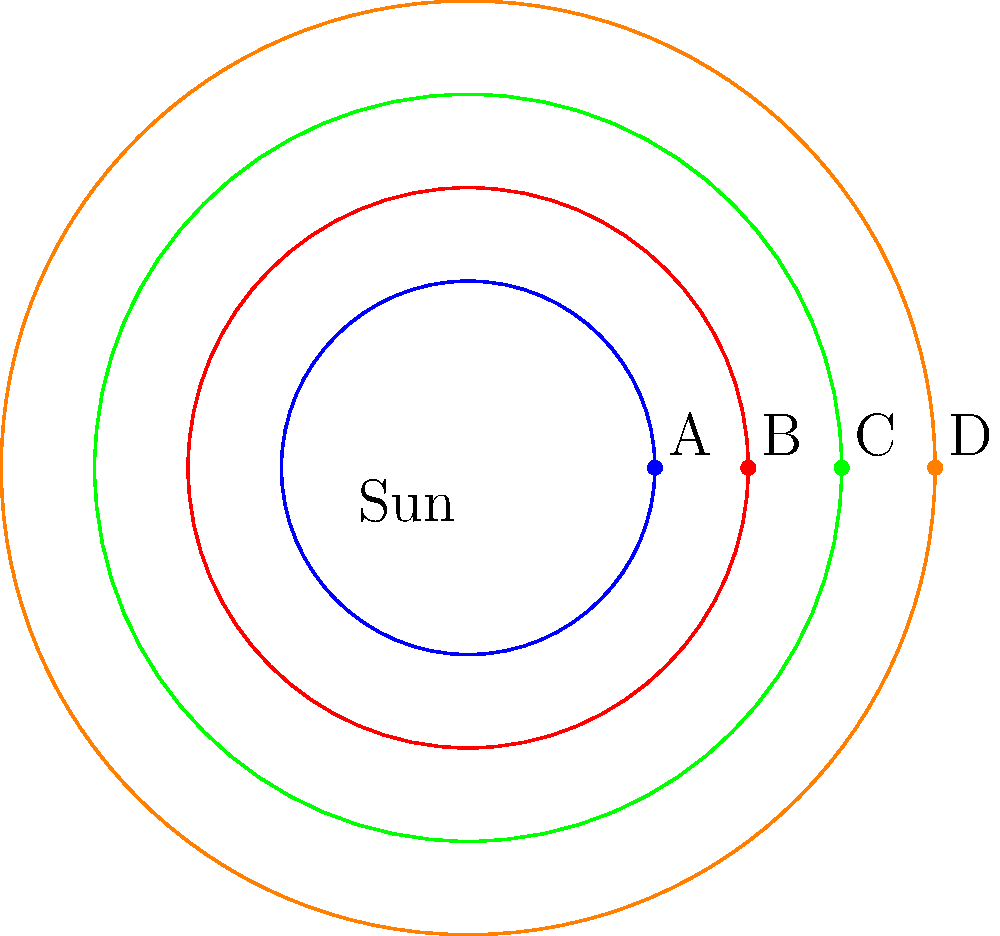In this simplified 2D representation of planetary orbits, which planet would experience the strongest gravitational pull from the Sun, and how would this affect the cognitive function of potential inhabitants if we consider the impact of extreme gravitational environments on the brain? To answer this question, we need to consider several factors:

1. Gravitational force: According to Newton's law of universal gravitation, the force of gravity is inversely proportional to the square of the distance between two objects. In this case, the closer a planet is to the Sun, the stronger the gravitational force it experiences.

2. Orbital distance: In the diagram, planet A is closest to the Sun, followed by B, C, and D in increasing order of distance.

3. Gravitational effects on the brain: Extreme gravitational environments can have significant impacts on cognitive function due to:
   a) Changes in cerebral blood flow
   b) Alterations in intracranial pressure
   c) Potential structural changes in brain tissue

4. Cognitive implications: Stronger gravitational forces could lead to:
   a) Increased cognitive load for basic motor functions
   b) Potential impairments in spatial orientation and balance
   c) Alterations in neurotransmitter function due to changes in fluid dynamics within the brain

5. Adaptation: Over time, inhabitants might develop neural plasticity to adapt to the gravitational environment, potentially leading to unique cognitive strengths or weaknesses.

Therefore, planet A would experience the strongest gravitational pull from the Sun. Inhabitants on this planet would likely face the most significant cognitive challenges due to the extreme gravitational environment, potentially requiring extensive neural adaptations to maintain normal cognitive function.
Answer: Planet A; increased cognitive load and potential impairments in spatial orientation and balance. 